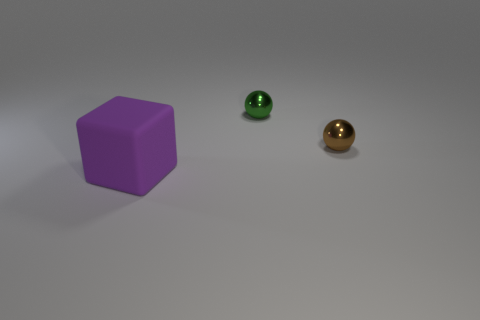Add 2 purple cylinders. How many objects exist? 5 Subtract all blocks. How many objects are left? 2 Add 3 cubes. How many cubes exist? 4 Subtract 0 cyan blocks. How many objects are left? 3 Subtract all large gray cylinders. Subtract all rubber cubes. How many objects are left? 2 Add 1 big matte objects. How many big matte objects are left? 2 